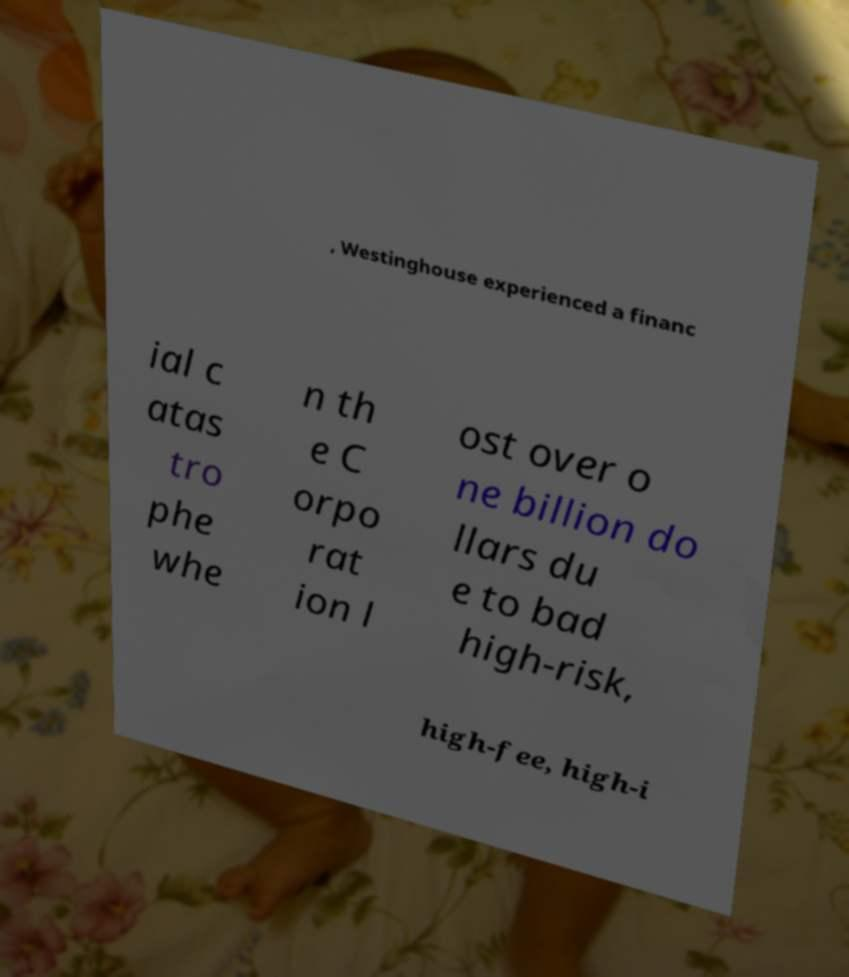I need the written content from this picture converted into text. Can you do that? , Westinghouse experienced a financ ial c atas tro phe whe n th e C orpo rat ion l ost over o ne billion do llars du e to bad high-risk, high-fee, high-i 